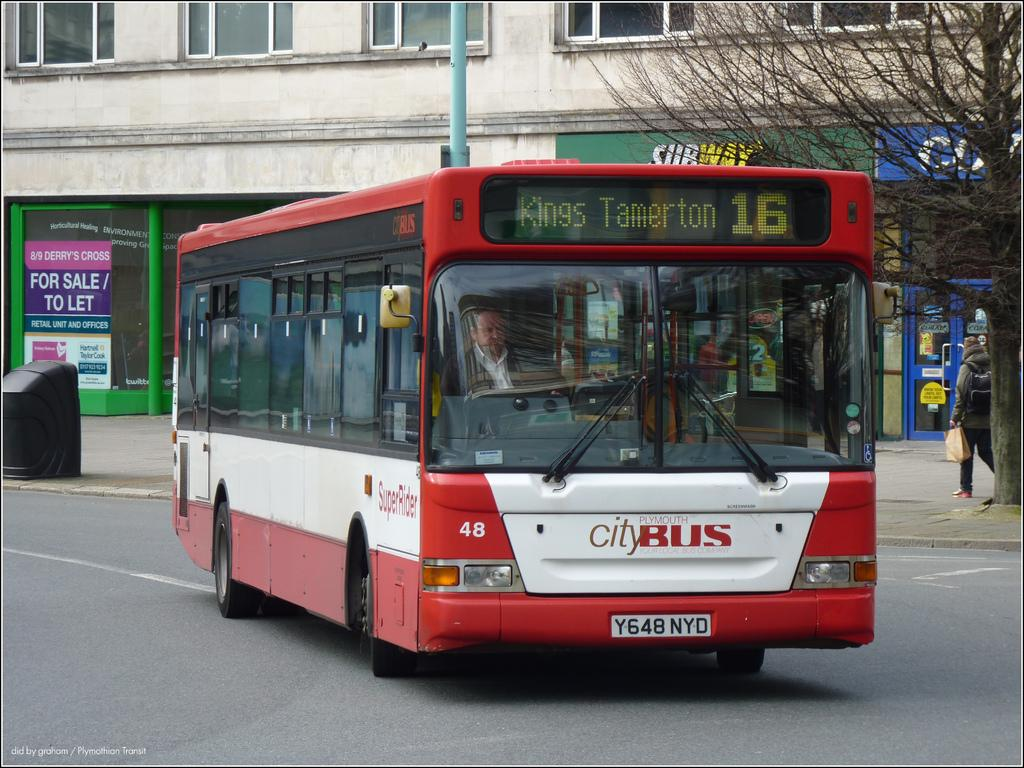<image>
Provide a brief description of the given image. A red and white city bus is headed to Kings Tamerton. 